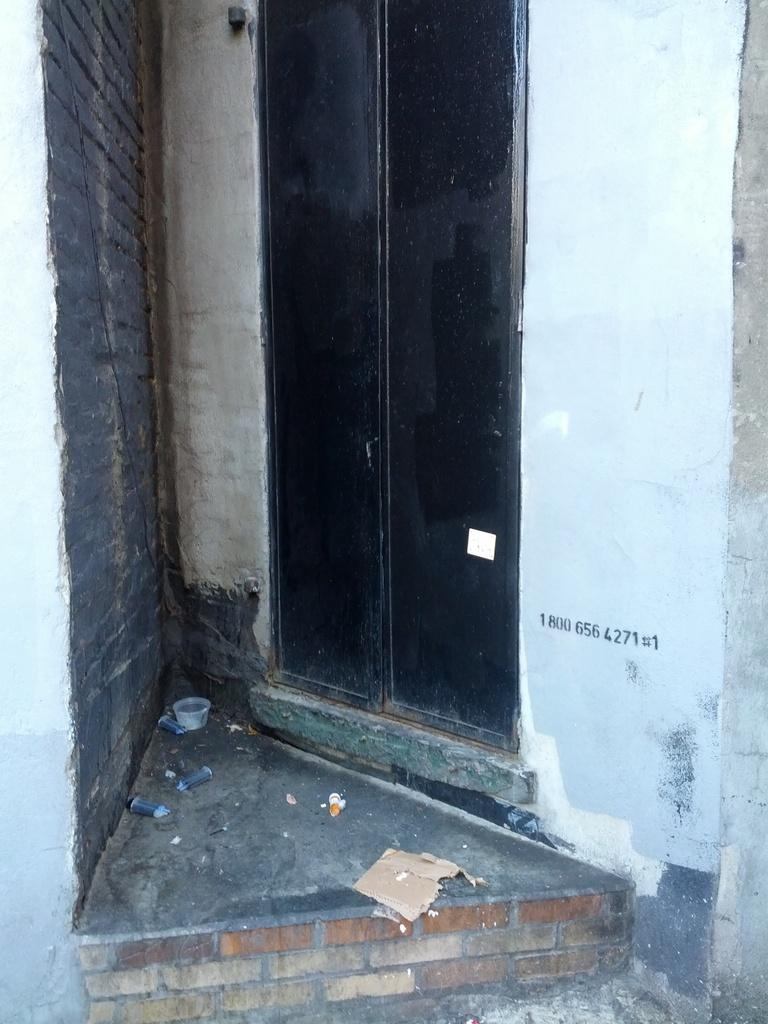How would you summarize this image in a sentence or two? In the picture I can see door to the wall 